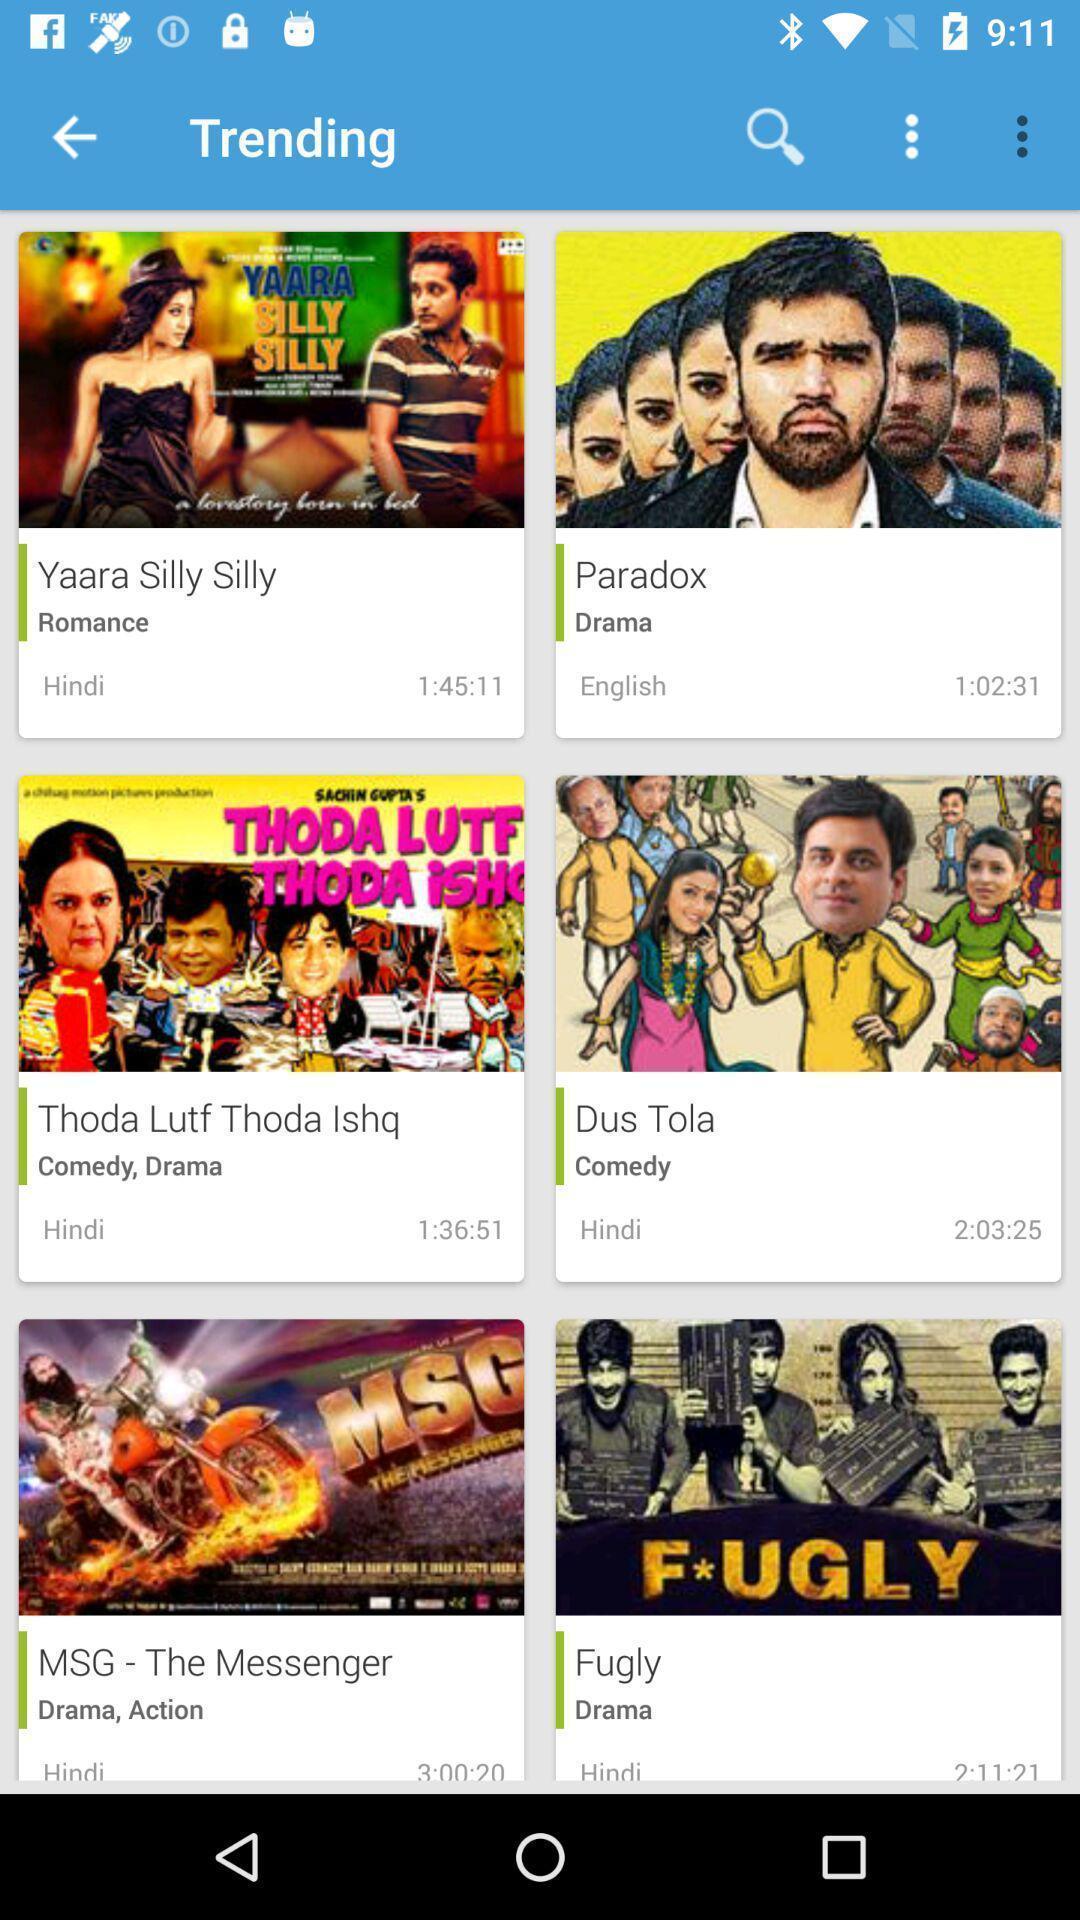Provide a detailed account of this screenshot. Trending movies page in an entertainment app. 